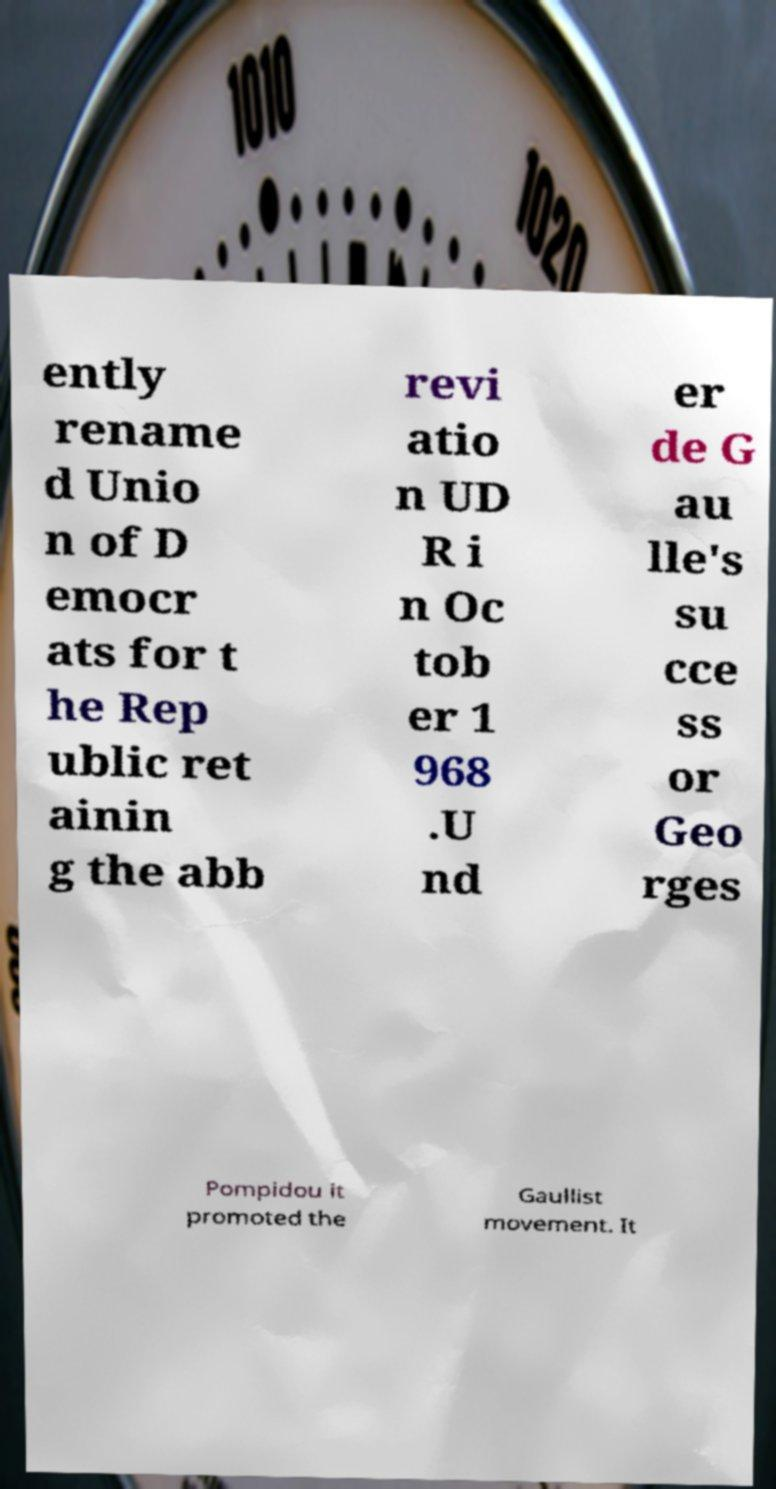I need the written content from this picture converted into text. Can you do that? ently rename d Unio n of D emocr ats for t he Rep ublic ret ainin g the abb revi atio n UD R i n Oc tob er 1 968 .U nd er de G au lle's su cce ss or Geo rges Pompidou it promoted the Gaullist movement. It 